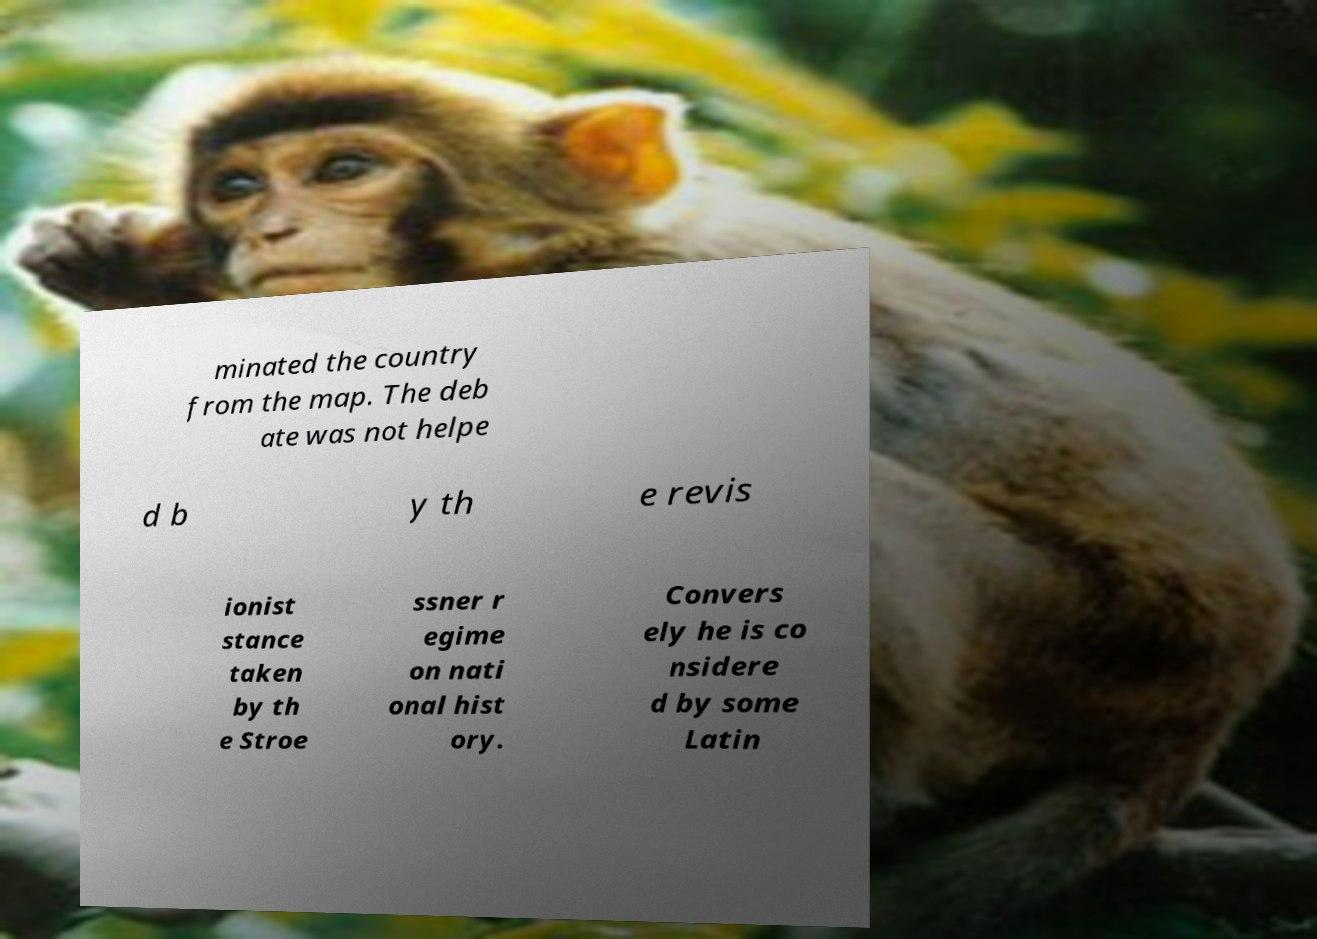Can you read and provide the text displayed in the image?This photo seems to have some interesting text. Can you extract and type it out for me? minated the country from the map. The deb ate was not helpe d b y th e revis ionist stance taken by th e Stroe ssner r egime on nati onal hist ory. Convers ely he is co nsidere d by some Latin 